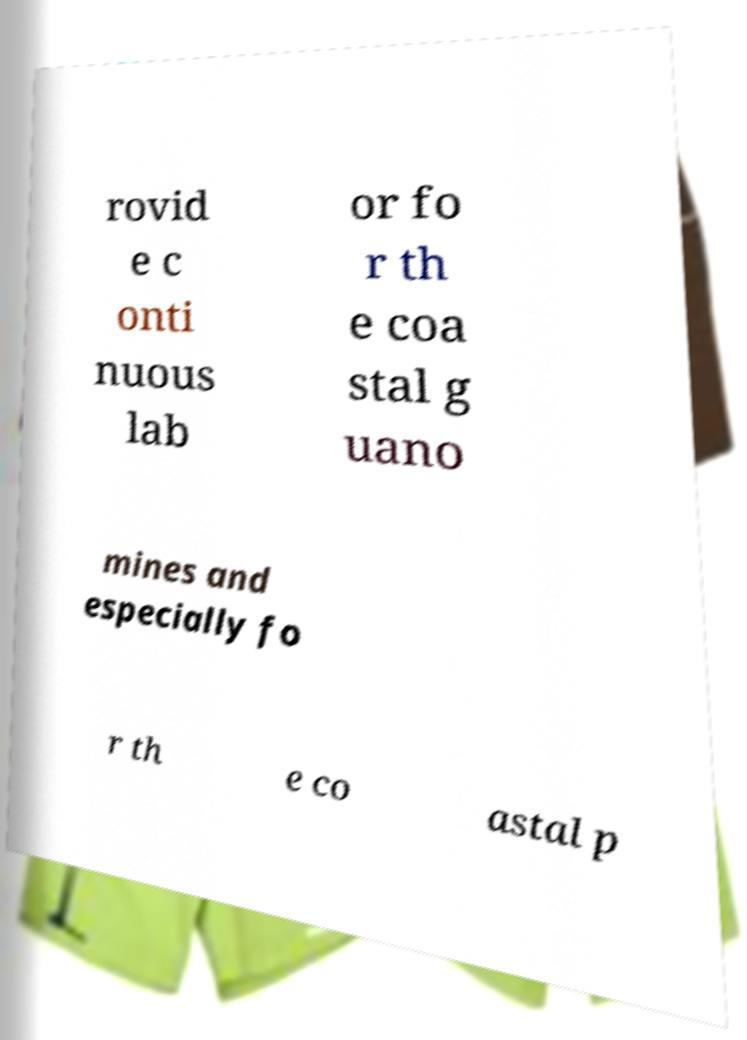Can you read and provide the text displayed in the image?This photo seems to have some interesting text. Can you extract and type it out for me? rovid e c onti nuous lab or fo r th e coa stal g uano mines and especially fo r th e co astal p 